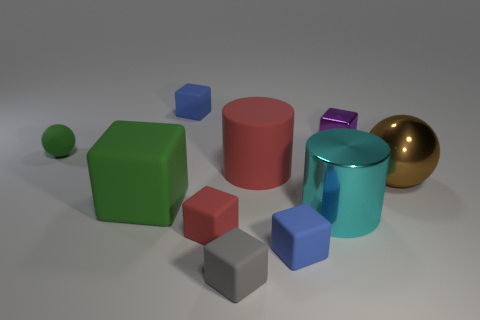Subtract all tiny blocks. How many blocks are left? 1 Subtract all blue cubes. How many cubes are left? 4 Subtract 1 cylinders. How many cylinders are left? 1 Subtract all purple balls. Subtract all purple cubes. How many balls are left? 2 Subtract all red cylinders. How many gray balls are left? 0 Subtract all red objects. Subtract all small purple objects. How many objects are left? 7 Add 8 gray rubber blocks. How many gray rubber blocks are left? 9 Add 6 red matte blocks. How many red matte blocks exist? 7 Subtract 1 cyan cylinders. How many objects are left? 9 Subtract all blocks. How many objects are left? 4 